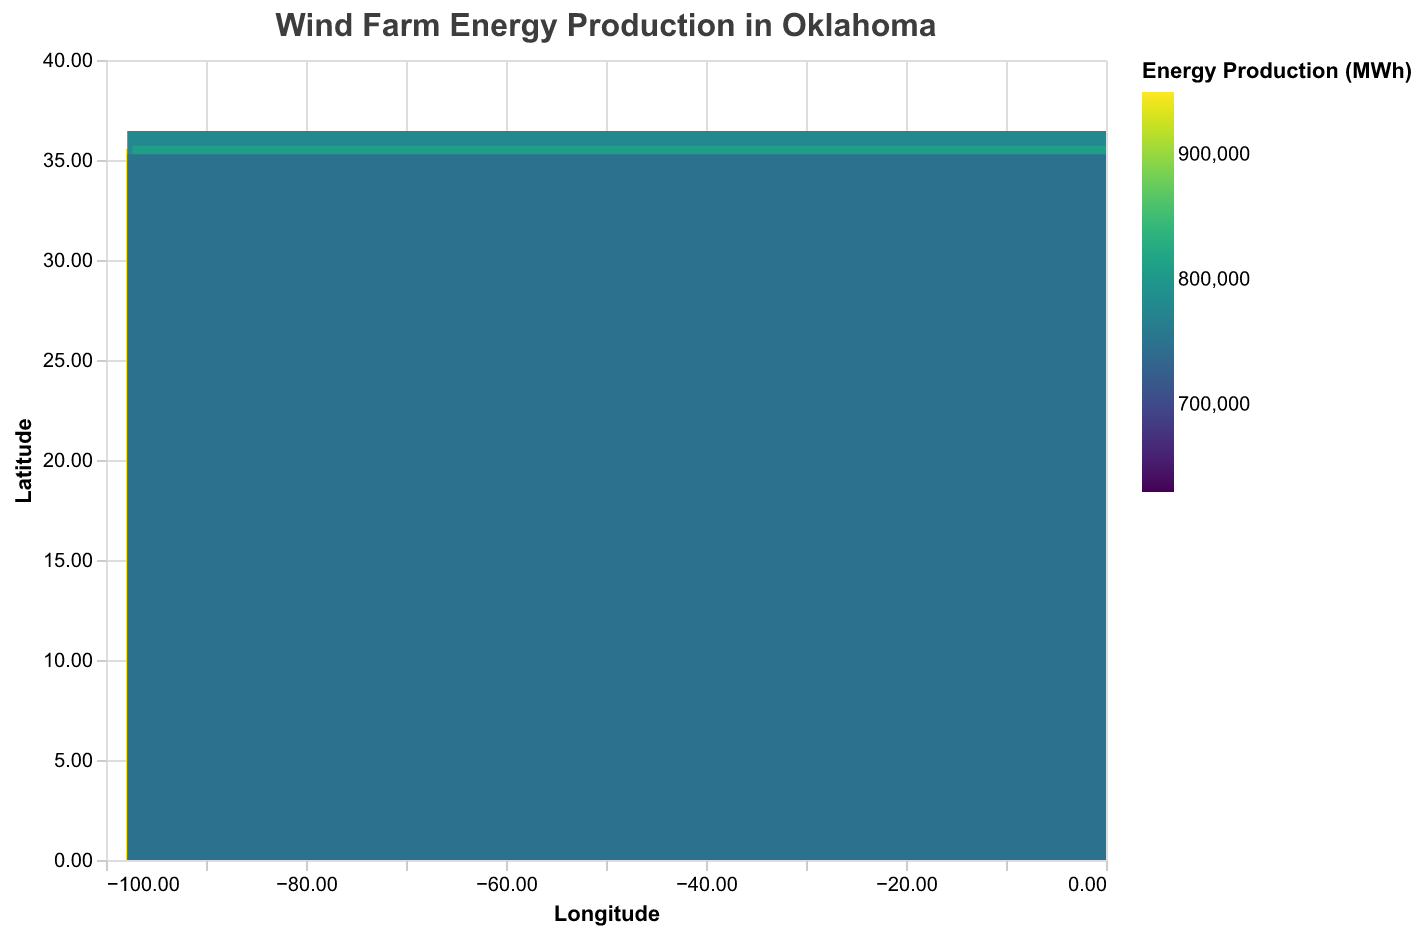How many wind farms are located in Logan County? By looking at the tooltip information in the heatmap, there are two data points with the County field as "Logan County".
Answer: 2 Which wind farm has the highest energy production in MWh? The color intensity in the heatmap indicates the energy production levels, and the tooltip shows specific values. The "Blue Canyon Wind Farm" has an energy production of 950,000 MWh, which is the highest on the map.
Answer: Blue Canyon Wind Farm Are there any wind farms in Oklahoma County, and if so, how many? The heatmap allows us to see the tooltip data showing two markers in "Oklahoma County": "Red Hills Wind Farm" and "Winds of the Prairies".
Answer: 2 Which wind farm produces more energy, the "Great Plains Wind Farm" or the "Noble Wind Project"? By comparing the tooltip data of the two wind farms, "Great Plains Wind Farm" has 800,000 MWh, and "Noble Wind Project" has 720,000 MWh. Therefore, "Great Plains Wind Farm" produces more energy.
Answer: Great Plains Wind Farm What is the coordinate location of the wind farm with the lowest installed capacity? The tooltip information shows that the "Thunderbird Wind Project" in Lincoln County has the lowest installed capacity at 95 MW. Its coordinates are Latitude: 35.6545 and Longitude: -96.3952.
Answer: Latitude 35.6545, Longitude -96.3952 How does the energy production of "High Plains Energy Project" compare to "Frontier Wind Farm"? The "High Plains Energy Project" produces 780,000 MWh, and the "Frontier Wind Farm" produces 810,000 MWh. Therefore, "Frontier Wind Farm" has a higher energy production by 30,000 MWh.
Answer: Frontier Wind Farm produces more What is the average energy production of the wind farms located in Oklahoma County? The two wind farms in Oklahoma County are "Red Hills Wind Farm" with 850,000 MWh and "Winds of the Prairies" with 680,000 MWh. To get the average: (850,000 + 680,000) / 2 = 765,000 MWh
Answer: 765,000 MWh Which county has the wind farm with the highest installed capacity? By checking the tooltip data, "Blue Canyon Wind Farm" in Canadian County has the highest installed capacity at 140 MW.
Answer: Canadian County 